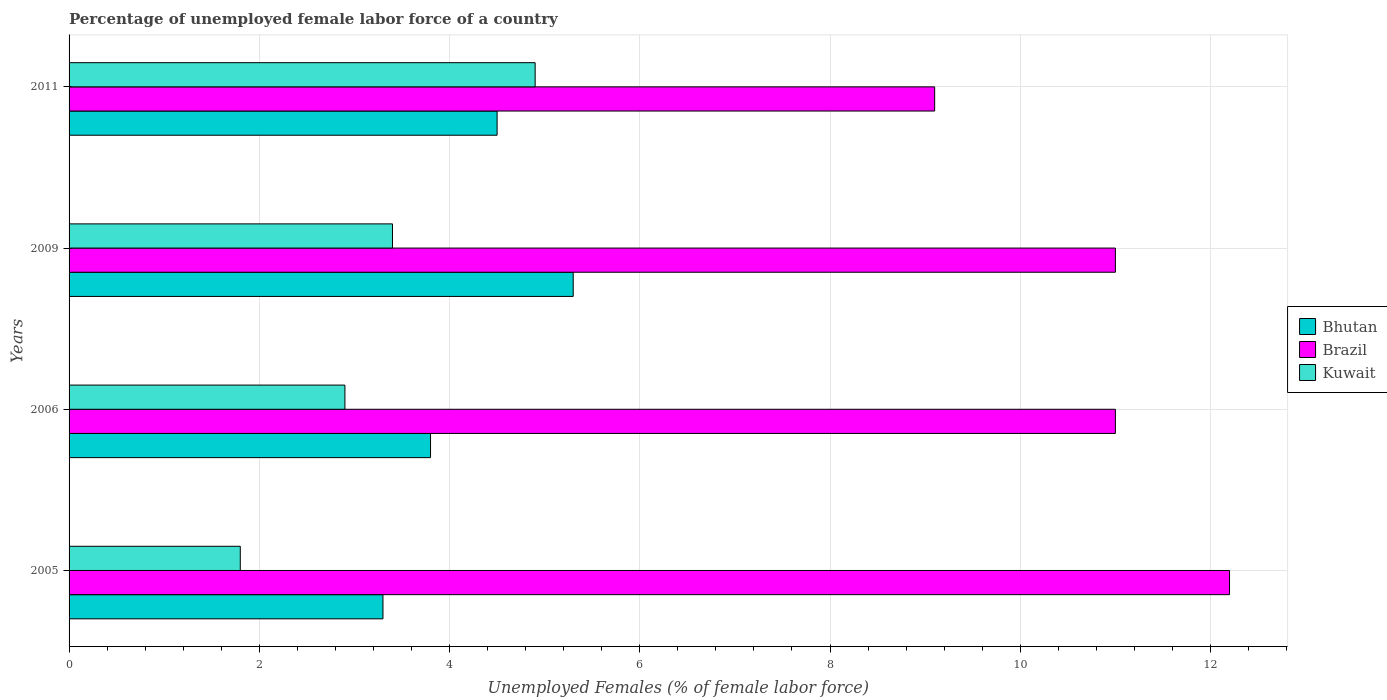How many different coloured bars are there?
Offer a very short reply. 3. How many groups of bars are there?
Your response must be concise. 4. Are the number of bars per tick equal to the number of legend labels?
Keep it short and to the point. Yes. Are the number of bars on each tick of the Y-axis equal?
Ensure brevity in your answer.  Yes. How many bars are there on the 4th tick from the top?
Your answer should be very brief. 3. How many bars are there on the 4th tick from the bottom?
Make the answer very short. 3. What is the label of the 1st group of bars from the top?
Ensure brevity in your answer.  2011. In how many cases, is the number of bars for a given year not equal to the number of legend labels?
Provide a short and direct response. 0. What is the percentage of unemployed female labor force in Kuwait in 2006?
Make the answer very short. 2.9. Across all years, what is the maximum percentage of unemployed female labor force in Bhutan?
Your response must be concise. 5.3. Across all years, what is the minimum percentage of unemployed female labor force in Brazil?
Provide a short and direct response. 9.1. In which year was the percentage of unemployed female labor force in Brazil minimum?
Ensure brevity in your answer.  2011. What is the total percentage of unemployed female labor force in Bhutan in the graph?
Keep it short and to the point. 16.9. What is the difference between the percentage of unemployed female labor force in Bhutan in 2009 and that in 2011?
Offer a terse response. 0.8. What is the difference between the percentage of unemployed female labor force in Kuwait in 2006 and the percentage of unemployed female labor force in Bhutan in 2009?
Give a very brief answer. -2.4. What is the average percentage of unemployed female labor force in Kuwait per year?
Offer a terse response. 3.25. In the year 2006, what is the difference between the percentage of unemployed female labor force in Kuwait and percentage of unemployed female labor force in Brazil?
Provide a short and direct response. -8.1. What is the ratio of the percentage of unemployed female labor force in Bhutan in 2005 to that in 2011?
Keep it short and to the point. 0.73. Is the percentage of unemployed female labor force in Kuwait in 2005 less than that in 2006?
Provide a succinct answer. Yes. What is the difference between the highest and the second highest percentage of unemployed female labor force in Bhutan?
Ensure brevity in your answer.  0.8. What is the difference between the highest and the lowest percentage of unemployed female labor force in Brazil?
Provide a short and direct response. 3.1. In how many years, is the percentage of unemployed female labor force in Kuwait greater than the average percentage of unemployed female labor force in Kuwait taken over all years?
Make the answer very short. 2. What does the 3rd bar from the top in 2009 represents?
Keep it short and to the point. Bhutan. What does the 3rd bar from the bottom in 2009 represents?
Make the answer very short. Kuwait. Is it the case that in every year, the sum of the percentage of unemployed female labor force in Bhutan and percentage of unemployed female labor force in Brazil is greater than the percentage of unemployed female labor force in Kuwait?
Your answer should be very brief. Yes. How many years are there in the graph?
Keep it short and to the point. 4. Does the graph contain any zero values?
Ensure brevity in your answer.  No. Does the graph contain grids?
Ensure brevity in your answer.  Yes. Where does the legend appear in the graph?
Keep it short and to the point. Center right. How are the legend labels stacked?
Ensure brevity in your answer.  Vertical. What is the title of the graph?
Your answer should be very brief. Percentage of unemployed female labor force of a country. What is the label or title of the X-axis?
Your response must be concise. Unemployed Females (% of female labor force). What is the label or title of the Y-axis?
Provide a succinct answer. Years. What is the Unemployed Females (% of female labor force) in Bhutan in 2005?
Keep it short and to the point. 3.3. What is the Unemployed Females (% of female labor force) of Brazil in 2005?
Make the answer very short. 12.2. What is the Unemployed Females (% of female labor force) in Kuwait in 2005?
Give a very brief answer. 1.8. What is the Unemployed Females (% of female labor force) of Bhutan in 2006?
Your answer should be very brief. 3.8. What is the Unemployed Females (% of female labor force) of Brazil in 2006?
Give a very brief answer. 11. What is the Unemployed Females (% of female labor force) in Kuwait in 2006?
Your response must be concise. 2.9. What is the Unemployed Females (% of female labor force) in Bhutan in 2009?
Offer a terse response. 5.3. What is the Unemployed Females (% of female labor force) of Kuwait in 2009?
Your answer should be very brief. 3.4. What is the Unemployed Females (% of female labor force) in Brazil in 2011?
Keep it short and to the point. 9.1. What is the Unemployed Females (% of female labor force) of Kuwait in 2011?
Keep it short and to the point. 4.9. Across all years, what is the maximum Unemployed Females (% of female labor force) of Bhutan?
Ensure brevity in your answer.  5.3. Across all years, what is the maximum Unemployed Females (% of female labor force) of Brazil?
Provide a short and direct response. 12.2. Across all years, what is the maximum Unemployed Females (% of female labor force) of Kuwait?
Make the answer very short. 4.9. Across all years, what is the minimum Unemployed Females (% of female labor force) of Bhutan?
Your answer should be very brief. 3.3. Across all years, what is the minimum Unemployed Females (% of female labor force) in Brazil?
Your response must be concise. 9.1. Across all years, what is the minimum Unemployed Females (% of female labor force) of Kuwait?
Keep it short and to the point. 1.8. What is the total Unemployed Females (% of female labor force) in Bhutan in the graph?
Offer a very short reply. 16.9. What is the total Unemployed Females (% of female labor force) of Brazil in the graph?
Provide a short and direct response. 43.3. What is the difference between the Unemployed Females (% of female labor force) of Brazil in 2005 and that in 2006?
Ensure brevity in your answer.  1.2. What is the difference between the Unemployed Females (% of female labor force) in Brazil in 2005 and that in 2009?
Your response must be concise. 1.2. What is the difference between the Unemployed Females (% of female labor force) of Brazil in 2005 and that in 2011?
Offer a terse response. 3.1. What is the difference between the Unemployed Females (% of female labor force) of Kuwait in 2005 and that in 2011?
Make the answer very short. -3.1. What is the difference between the Unemployed Females (% of female labor force) in Bhutan in 2006 and that in 2009?
Offer a terse response. -1.5. What is the difference between the Unemployed Females (% of female labor force) in Brazil in 2006 and that in 2009?
Offer a terse response. 0. What is the difference between the Unemployed Females (% of female labor force) of Bhutan in 2006 and that in 2011?
Provide a succinct answer. -0.7. What is the difference between the Unemployed Females (% of female labor force) in Bhutan in 2009 and that in 2011?
Offer a very short reply. 0.8. What is the difference between the Unemployed Females (% of female labor force) of Bhutan in 2005 and the Unemployed Females (% of female labor force) of Brazil in 2009?
Offer a terse response. -7.7. What is the difference between the Unemployed Females (% of female labor force) of Bhutan in 2005 and the Unemployed Females (% of female labor force) of Brazil in 2011?
Your answer should be compact. -5.8. What is the difference between the Unemployed Females (% of female labor force) in Brazil in 2005 and the Unemployed Females (% of female labor force) in Kuwait in 2011?
Provide a short and direct response. 7.3. What is the difference between the Unemployed Females (% of female labor force) of Brazil in 2006 and the Unemployed Females (% of female labor force) of Kuwait in 2009?
Make the answer very short. 7.6. What is the difference between the Unemployed Females (% of female labor force) of Bhutan in 2006 and the Unemployed Females (% of female labor force) of Kuwait in 2011?
Give a very brief answer. -1.1. What is the difference between the Unemployed Females (% of female labor force) in Brazil in 2006 and the Unemployed Females (% of female labor force) in Kuwait in 2011?
Make the answer very short. 6.1. What is the difference between the Unemployed Females (% of female labor force) in Bhutan in 2009 and the Unemployed Females (% of female labor force) in Kuwait in 2011?
Your answer should be very brief. 0.4. What is the average Unemployed Females (% of female labor force) in Bhutan per year?
Your response must be concise. 4.22. What is the average Unemployed Females (% of female labor force) of Brazil per year?
Your response must be concise. 10.82. In the year 2005, what is the difference between the Unemployed Females (% of female labor force) in Brazil and Unemployed Females (% of female labor force) in Kuwait?
Ensure brevity in your answer.  10.4. In the year 2006, what is the difference between the Unemployed Females (% of female labor force) in Bhutan and Unemployed Females (% of female labor force) in Brazil?
Give a very brief answer. -7.2. In the year 2006, what is the difference between the Unemployed Females (% of female labor force) of Brazil and Unemployed Females (% of female labor force) of Kuwait?
Ensure brevity in your answer.  8.1. In the year 2009, what is the difference between the Unemployed Females (% of female labor force) in Bhutan and Unemployed Females (% of female labor force) in Brazil?
Provide a succinct answer. -5.7. In the year 2009, what is the difference between the Unemployed Females (% of female labor force) of Brazil and Unemployed Females (% of female labor force) of Kuwait?
Keep it short and to the point. 7.6. In the year 2011, what is the difference between the Unemployed Females (% of female labor force) of Bhutan and Unemployed Females (% of female labor force) of Brazil?
Your answer should be very brief. -4.6. In the year 2011, what is the difference between the Unemployed Females (% of female labor force) in Brazil and Unemployed Females (% of female labor force) in Kuwait?
Give a very brief answer. 4.2. What is the ratio of the Unemployed Females (% of female labor force) of Bhutan in 2005 to that in 2006?
Provide a succinct answer. 0.87. What is the ratio of the Unemployed Females (% of female labor force) in Brazil in 2005 to that in 2006?
Your answer should be compact. 1.11. What is the ratio of the Unemployed Females (% of female labor force) of Kuwait in 2005 to that in 2006?
Your response must be concise. 0.62. What is the ratio of the Unemployed Females (% of female labor force) in Bhutan in 2005 to that in 2009?
Your answer should be compact. 0.62. What is the ratio of the Unemployed Females (% of female labor force) in Brazil in 2005 to that in 2009?
Offer a terse response. 1.11. What is the ratio of the Unemployed Females (% of female labor force) of Kuwait in 2005 to that in 2009?
Provide a succinct answer. 0.53. What is the ratio of the Unemployed Females (% of female labor force) in Bhutan in 2005 to that in 2011?
Give a very brief answer. 0.73. What is the ratio of the Unemployed Females (% of female labor force) of Brazil in 2005 to that in 2011?
Provide a short and direct response. 1.34. What is the ratio of the Unemployed Females (% of female labor force) in Kuwait in 2005 to that in 2011?
Offer a very short reply. 0.37. What is the ratio of the Unemployed Females (% of female labor force) in Bhutan in 2006 to that in 2009?
Give a very brief answer. 0.72. What is the ratio of the Unemployed Females (% of female labor force) in Kuwait in 2006 to that in 2009?
Make the answer very short. 0.85. What is the ratio of the Unemployed Females (% of female labor force) of Bhutan in 2006 to that in 2011?
Make the answer very short. 0.84. What is the ratio of the Unemployed Females (% of female labor force) in Brazil in 2006 to that in 2011?
Your response must be concise. 1.21. What is the ratio of the Unemployed Females (% of female labor force) of Kuwait in 2006 to that in 2011?
Offer a very short reply. 0.59. What is the ratio of the Unemployed Females (% of female labor force) of Bhutan in 2009 to that in 2011?
Your answer should be compact. 1.18. What is the ratio of the Unemployed Females (% of female labor force) in Brazil in 2009 to that in 2011?
Your answer should be compact. 1.21. What is the ratio of the Unemployed Females (% of female labor force) of Kuwait in 2009 to that in 2011?
Offer a very short reply. 0.69. What is the difference between the highest and the second highest Unemployed Females (% of female labor force) in Kuwait?
Offer a terse response. 1.5. What is the difference between the highest and the lowest Unemployed Females (% of female labor force) of Bhutan?
Your answer should be very brief. 2. What is the difference between the highest and the lowest Unemployed Females (% of female labor force) in Kuwait?
Your answer should be very brief. 3.1. 